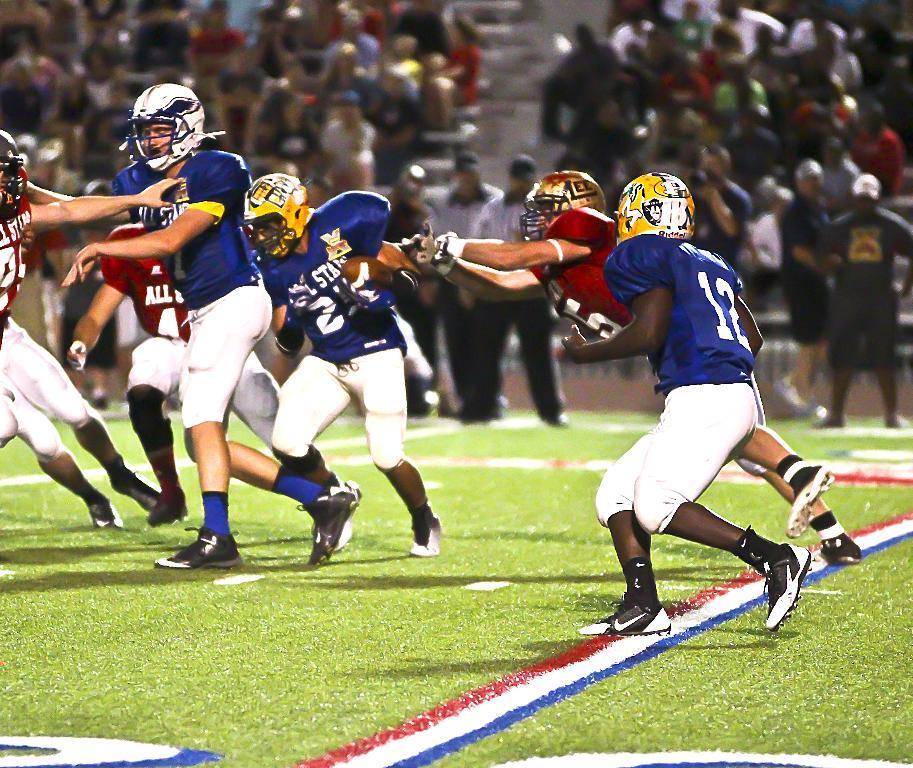Describe this image in one or two sentences. In this image I can see group of people playing game. In front the person is wearing blue and white color dress and white color helmet. In the background I can see group of people sitting. 